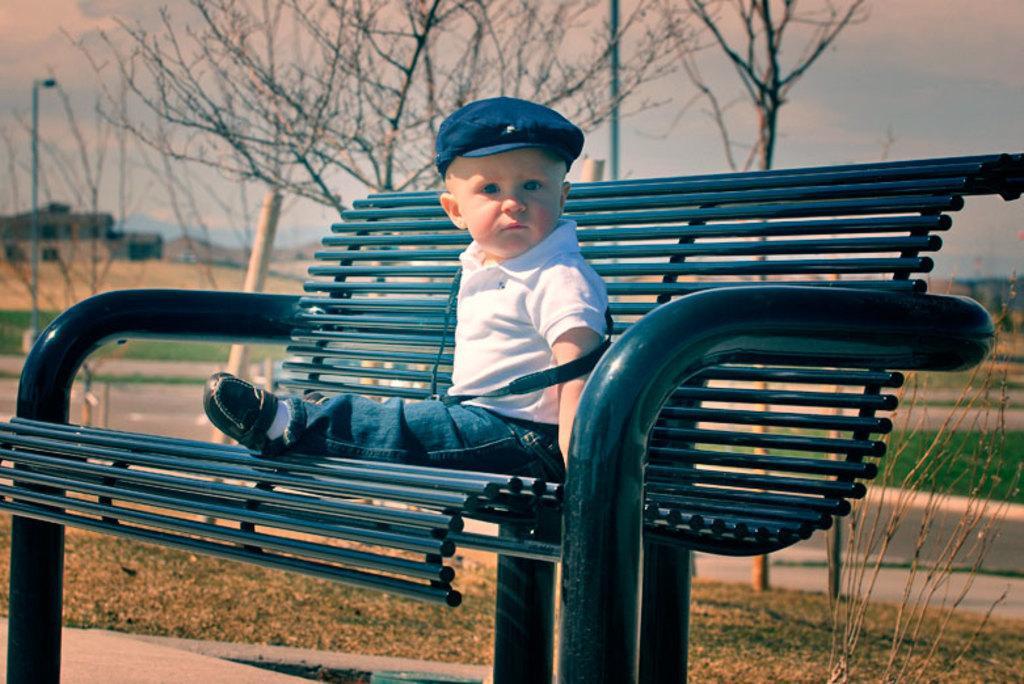Could you give a brief overview of what you see in this image? In this image we can see a child sitting on the bench. In the background we can see trees and building. 